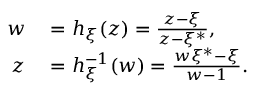<formula> <loc_0><loc_0><loc_500><loc_500>\begin{array} { r l } { w } & = h _ { \xi } ( z ) = \frac { z - \xi } { z - \xi ^ { * } } , } \\ { z } & = h _ { \xi } ^ { - 1 } ( w ) = \frac { w \xi ^ { * } - \xi } { w - 1 } . } \end{array}</formula> 